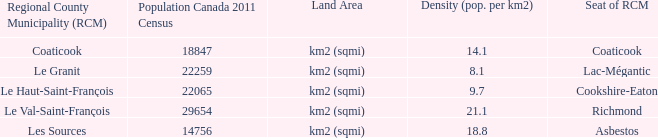7? Cookshire-Eaton. 